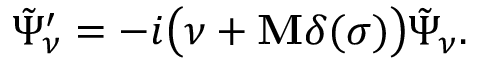Convert formula to latex. <formula><loc_0><loc_0><loc_500><loc_500>\tilde { \Psi } _ { \nu } ^ { \prime } = - i \left ( \nu + { M } \delta ( \sigma ) \right ) \tilde { \Psi } _ { \nu } .</formula> 